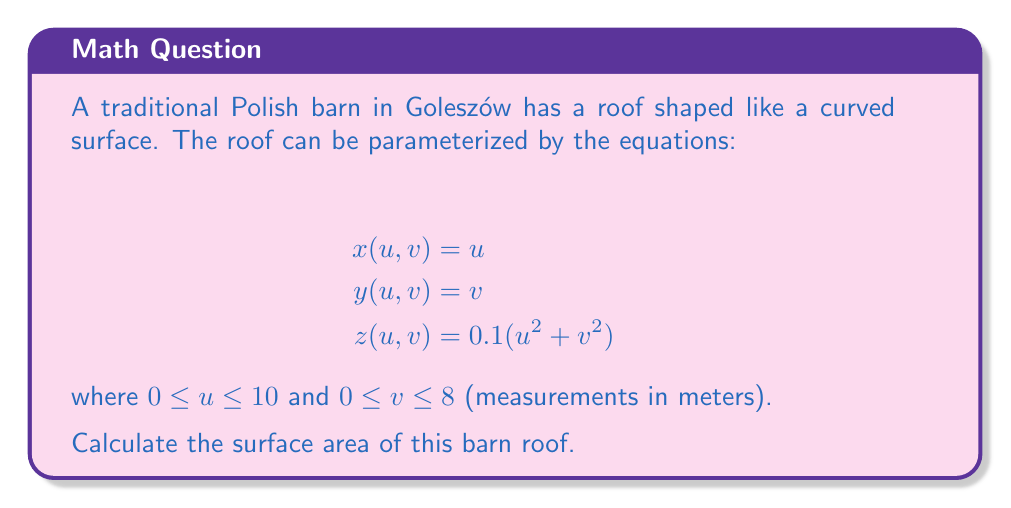Show me your answer to this math problem. To find the surface area, we need to use the formula for the surface area of a parametric surface:

$$A = \iint_R \sqrt{EG - F^2} \, dudv$$

where $E = x_u^2 + y_u^2 + z_u^2$, $F = x_ux_v + y_uy_v + z_uz_v$, and $G = x_v^2 + y_v^2 + z_v^2$.

Step 1: Calculate partial derivatives
$x_u = 1$, $x_v = 0$
$y_u = 0$, $y_v = 1$
$z_u = 0.2u$, $z_v = 0.2v$

Step 2: Calculate E, F, and G
$E = 1^2 + 0^2 + (0.2u)^2 = 1 + 0.04u^2$
$F = (1)(0) + (0)(1) + (0.2u)(0.2v) = 0.04uv$
$G = 0^2 + 1^2 + (0.2v)^2 = 1 + 0.04v^2$

Step 3: Calculate the integrand
$$\sqrt{EG - F^2} = \sqrt{(1 + 0.04u^2)(1 + 0.04v^2) - (0.04uv)^2}$$
$$= \sqrt{1 + 0.04u^2 + 0.04v^2 + 0.0016u^2v^2 - 0.0016u^2v^2}$$
$$= \sqrt{1 + 0.04u^2 + 0.04v^2}$$

Step 4: Set up and evaluate the double integral
$$A = \int_0^8 \int_0^{10} \sqrt{1 + 0.04u^2 + 0.04v^2} \, dudv$$

This integral cannot be evaluated analytically, so we need to use numerical methods to approximate the result. Using a computer algebra system or numerical integration tool, we find:

$$A \approx 84.26 \text{ m}^2$$
Answer: $84.26 \text{ m}^2$ 